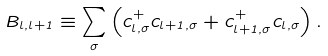<formula> <loc_0><loc_0><loc_500><loc_500>B _ { l , l + 1 } \equiv \sum _ { \sigma } \left ( c _ { l , \sigma } ^ { + } c _ { l + 1 , \sigma } + c _ { l + 1 , \sigma } ^ { + } c _ { l , \sigma } \right ) .</formula> 